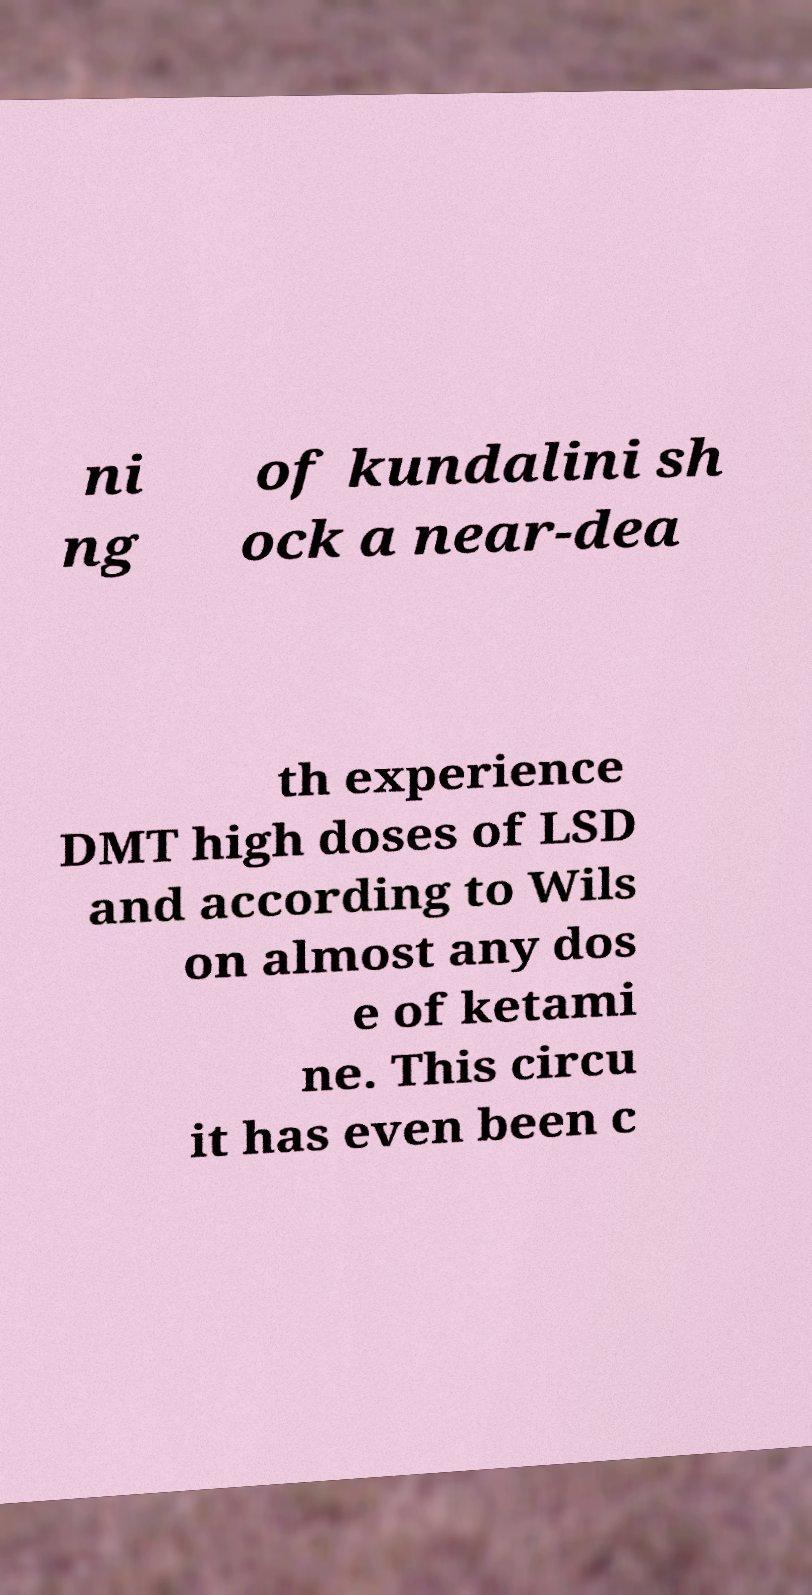Please identify and transcribe the text found in this image. ni ng of kundalini sh ock a near-dea th experience DMT high doses of LSD and according to Wils on almost any dos e of ketami ne. This circu it has even been c 